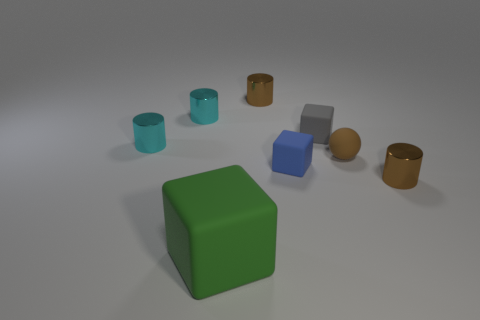There is a brown matte object on the right side of the small gray object; does it have the same size as the green object left of the tiny rubber ball?
Your answer should be very brief. No. There is a small rubber sphere; are there any gray objects on the right side of it?
Keep it short and to the point. No. What is the color of the rubber thing on the left side of the tiny brown shiny thing left of the small brown rubber object?
Provide a succinct answer. Green. Are there fewer tiny cylinders than tiny gray things?
Your answer should be compact. No. What number of other big green rubber things are the same shape as the big green object?
Offer a very short reply. 0. There is a rubber sphere that is the same size as the blue thing; what color is it?
Provide a short and direct response. Brown. Is the number of large green things that are behind the ball the same as the number of brown metal cylinders that are behind the gray matte cube?
Offer a very short reply. No. Are there any balls that have the same size as the brown rubber thing?
Keep it short and to the point. No. What size is the blue object?
Provide a short and direct response. Small. Are there the same number of blue cubes that are left of the green thing and big purple shiny cubes?
Your answer should be compact. Yes. 